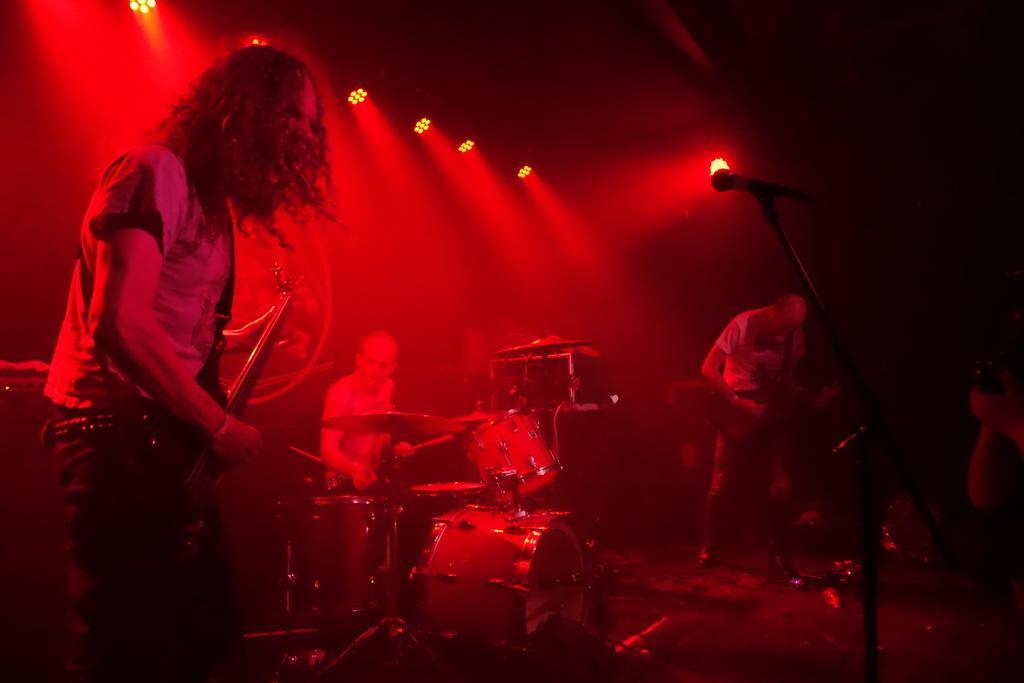Describe this image in one or two sentences. In this picture there is a man playing guitar and singing. There is another man playing guitar. There is a person sitting on the chair. There are drums and other musical instruments. There is a mic. There are some lights at the background. 